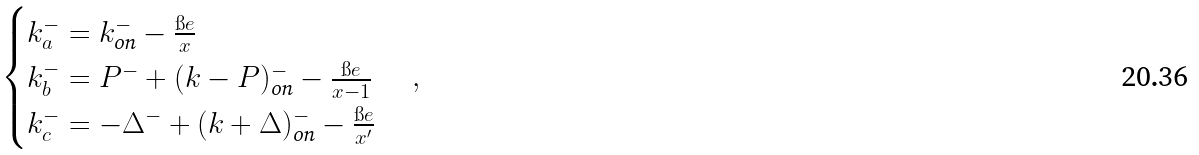Convert formula to latex. <formula><loc_0><loc_0><loc_500><loc_500>\begin{cases} k ^ { - } _ { a } = k ^ { - } _ { \text {on} } - \frac { \i e } { x } \\ k ^ { - } _ { b } = P ^ { - } + ( k - P ) ^ { - } _ { \text {on} } - \frac { \i e } { x - 1 } \\ k ^ { - } _ { c } = - \Delta ^ { - } + ( k + \Delta ) ^ { - } _ { \text {on} } - \frac { \i e } { x ^ { \prime } } \\ \end{cases} ,</formula> 